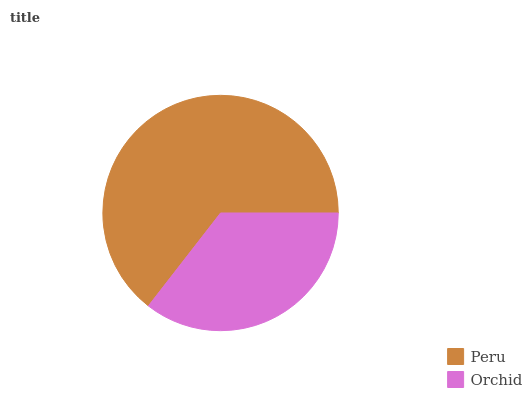Is Orchid the minimum?
Answer yes or no. Yes. Is Peru the maximum?
Answer yes or no. Yes. Is Orchid the maximum?
Answer yes or no. No. Is Peru greater than Orchid?
Answer yes or no. Yes. Is Orchid less than Peru?
Answer yes or no. Yes. Is Orchid greater than Peru?
Answer yes or no. No. Is Peru less than Orchid?
Answer yes or no. No. Is Peru the high median?
Answer yes or no. Yes. Is Orchid the low median?
Answer yes or no. Yes. Is Orchid the high median?
Answer yes or no. No. Is Peru the low median?
Answer yes or no. No. 